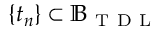<formula> <loc_0><loc_0><loc_500><loc_500>\{ t _ { n } \} \subset \mathbb { B } _ { T D L }</formula> 